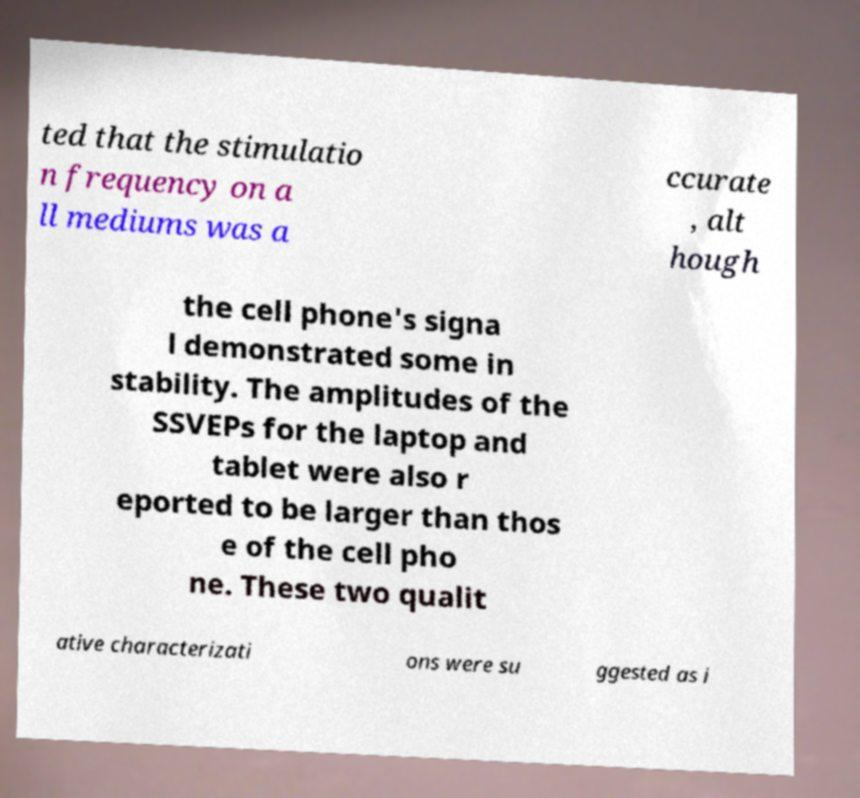There's text embedded in this image that I need extracted. Can you transcribe it verbatim? ted that the stimulatio n frequency on a ll mediums was a ccurate , alt hough the cell phone's signa l demonstrated some in stability. The amplitudes of the SSVEPs for the laptop and tablet were also r eported to be larger than thos e of the cell pho ne. These two qualit ative characterizati ons were su ggested as i 